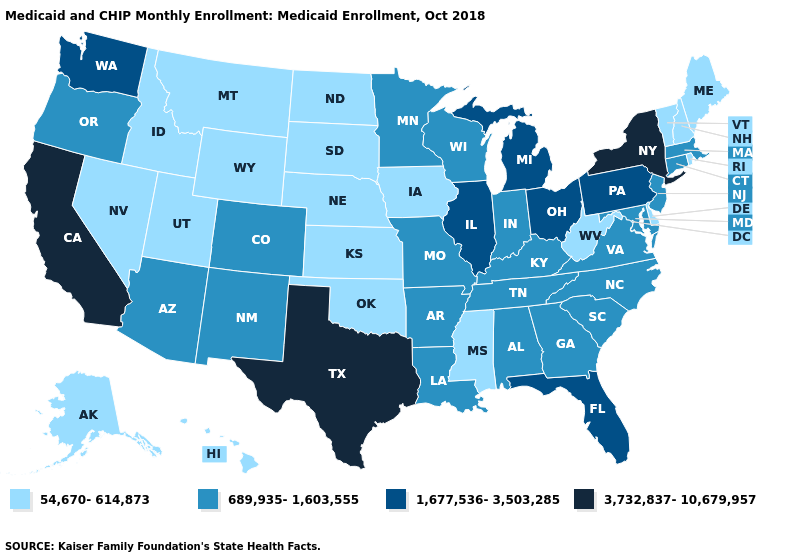What is the highest value in states that border Nebraska?
Short answer required. 689,935-1,603,555. Does Indiana have the same value as Wyoming?
Short answer required. No. Among the states that border Idaho , does Oregon have the lowest value?
Be succinct. No. What is the value of Arkansas?
Answer briefly. 689,935-1,603,555. Name the states that have a value in the range 54,670-614,873?
Short answer required. Alaska, Delaware, Hawaii, Idaho, Iowa, Kansas, Maine, Mississippi, Montana, Nebraska, Nevada, New Hampshire, North Dakota, Oklahoma, Rhode Island, South Dakota, Utah, Vermont, West Virginia, Wyoming. Does New York have the highest value in the Northeast?
Keep it brief. Yes. Does Connecticut have the lowest value in the USA?
Write a very short answer. No. Does West Virginia have the lowest value in the USA?
Answer briefly. Yes. What is the highest value in the West ?
Short answer required. 3,732,837-10,679,957. Does Louisiana have a higher value than Nevada?
Concise answer only. Yes. Does Mississippi have the lowest value in the South?
Quick response, please. Yes. Which states have the lowest value in the USA?
Be succinct. Alaska, Delaware, Hawaii, Idaho, Iowa, Kansas, Maine, Mississippi, Montana, Nebraska, Nevada, New Hampshire, North Dakota, Oklahoma, Rhode Island, South Dakota, Utah, Vermont, West Virginia, Wyoming. Does the map have missing data?
Write a very short answer. No. What is the value of California?
Quick response, please. 3,732,837-10,679,957. What is the value of California?
Give a very brief answer. 3,732,837-10,679,957. 